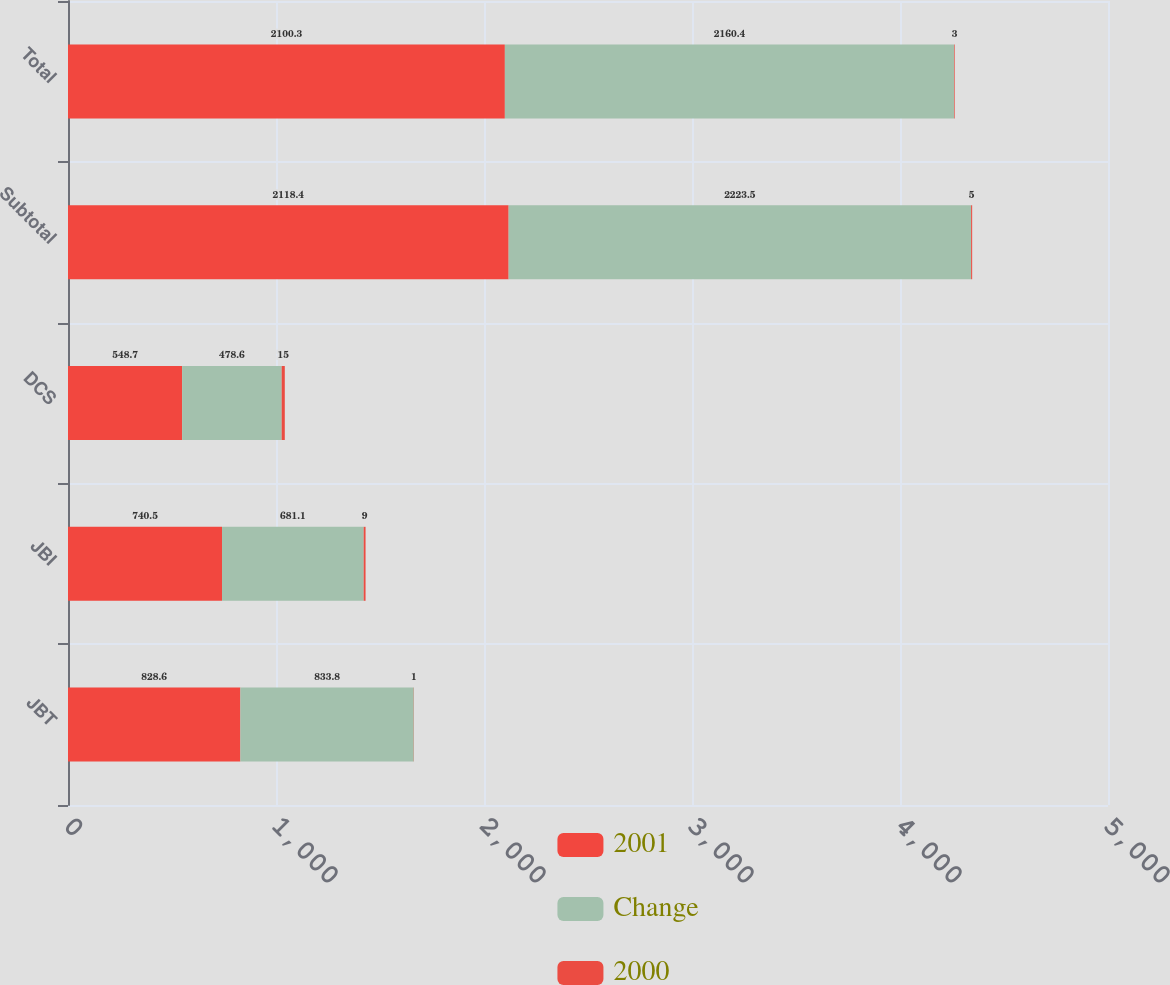Convert chart. <chart><loc_0><loc_0><loc_500><loc_500><stacked_bar_chart><ecel><fcel>JBT<fcel>JBI<fcel>DCS<fcel>Subtotal<fcel>Total<nl><fcel>2001<fcel>828.6<fcel>740.5<fcel>548.7<fcel>2118.4<fcel>2100.3<nl><fcel>Change<fcel>833.8<fcel>681.1<fcel>478.6<fcel>2223.5<fcel>2160.4<nl><fcel>2000<fcel>1<fcel>9<fcel>15<fcel>5<fcel>3<nl></chart> 